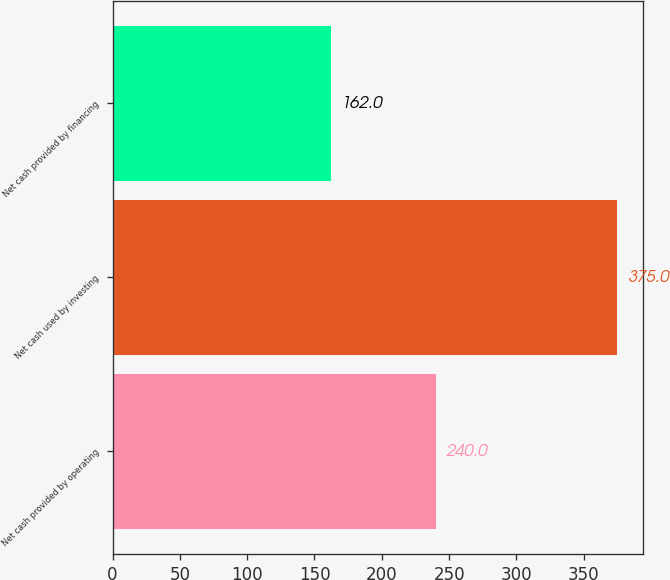<chart> <loc_0><loc_0><loc_500><loc_500><bar_chart><fcel>Net cash provided by operating<fcel>Net cash used by investing<fcel>Net cash provided by financing<nl><fcel>240<fcel>375<fcel>162<nl></chart> 